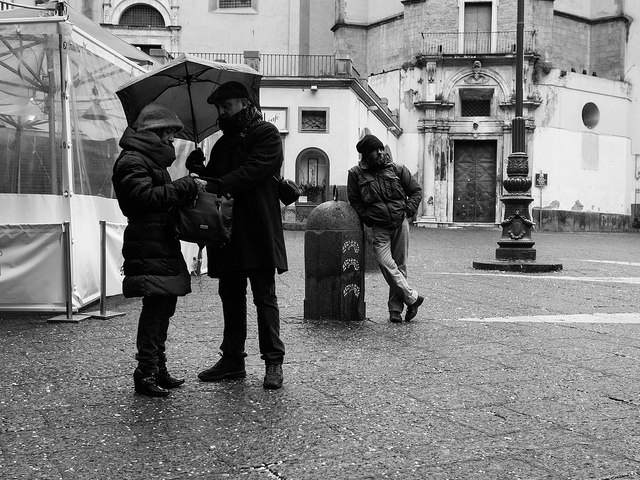<image>Where is the couple going? I don't know where the couple is going. The answers provided are too ambiguous to determine. Where is the couple going? I don't know where the couple is going. They could be going out, home, shopping, or anywhere else. 